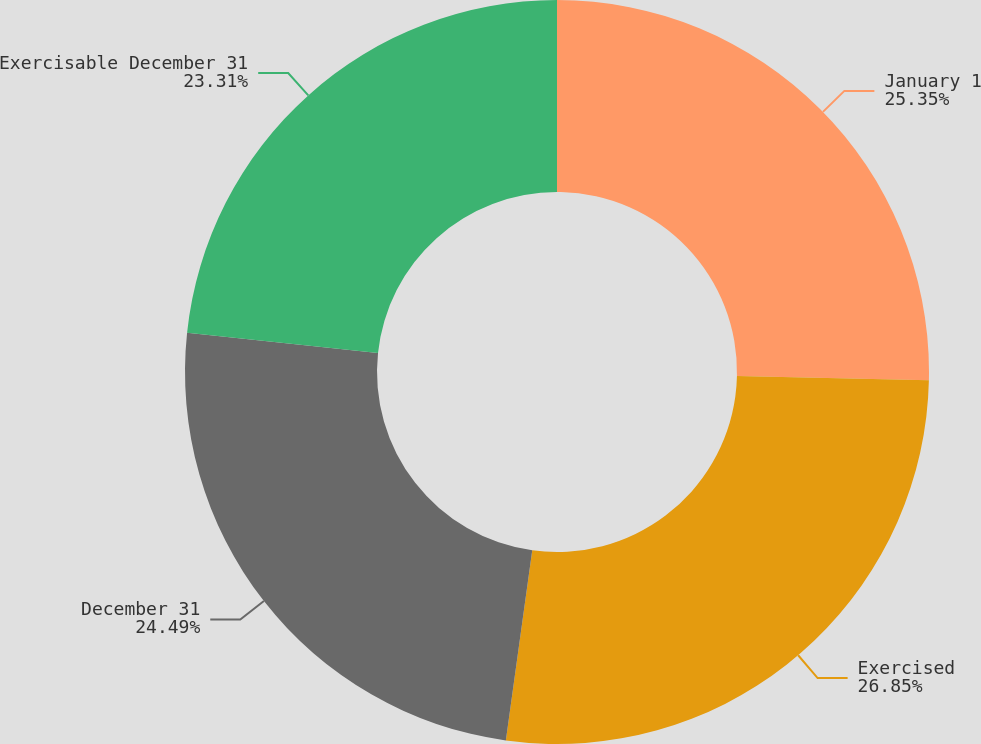Convert chart. <chart><loc_0><loc_0><loc_500><loc_500><pie_chart><fcel>January 1<fcel>Exercised<fcel>December 31<fcel>Exercisable December 31<nl><fcel>25.35%<fcel>26.84%<fcel>24.49%<fcel>23.31%<nl></chart> 